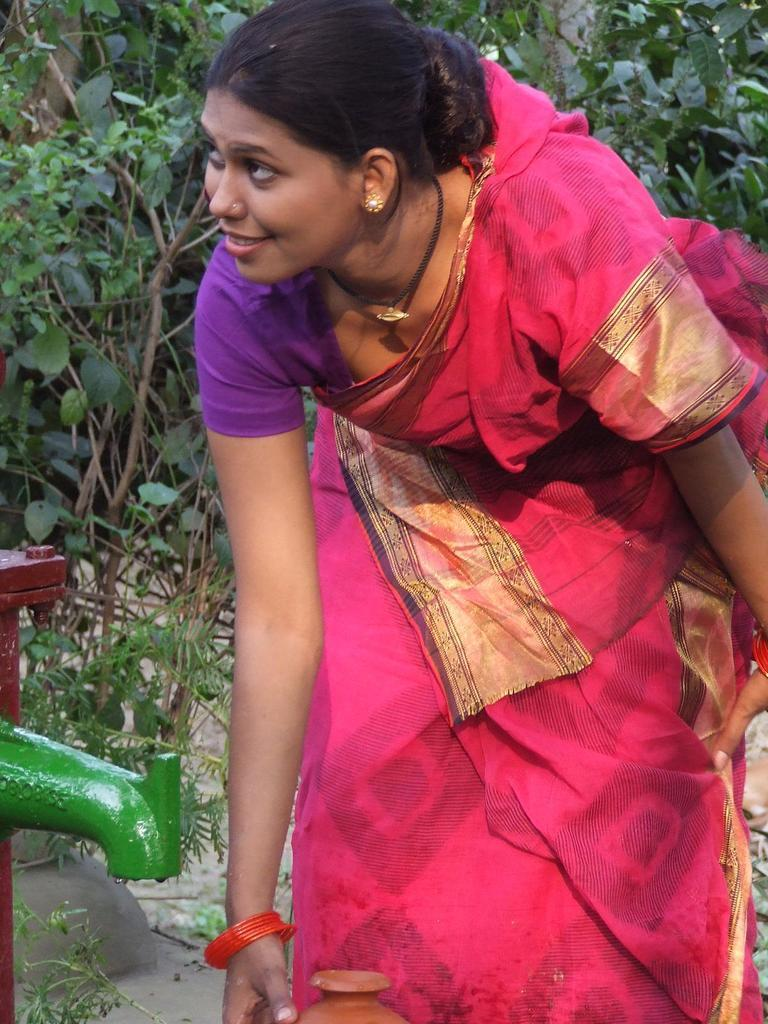Who is the main subject in the image? There is a lady in the image. What is the lady doing in the image? The lady is bending. What object is present near the lady? There is a tap in the image, and it is to the side of the lady. What can be seen in the background of the image? Trees are visible in the background of the image. What type of animal is present in the image? There is no animal present in the image. What class is the lady teaching in the image? The image does not depict a class or any teaching activity. 